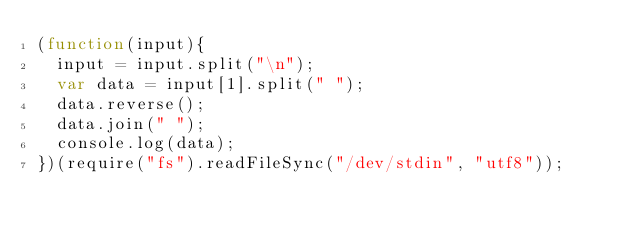<code> <loc_0><loc_0><loc_500><loc_500><_JavaScript_>(function(input){
	input = input.split("\n");
	var data = input[1].split(" ");
	data.reverse();
	data.join(" ");
	console.log(data);
})(require("fs").readFileSync("/dev/stdin", "utf8"));</code> 